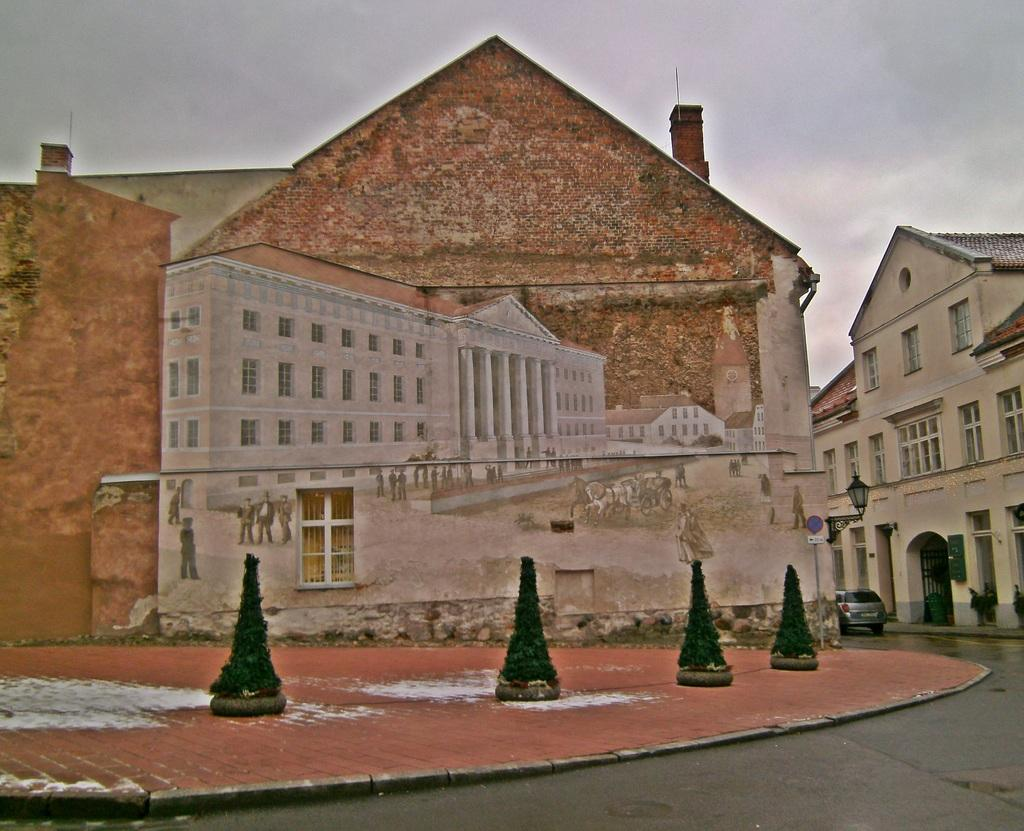What type of structures can be seen in the image? There are buildings in the image. What else can be found in the image besides buildings? There are plants, a motor vehicle, street lights, and a sign board in the image. What might be used for illumination at night in the image? Street lights are present in the image for illumination. What is visible in the background of the image? The sky is visible in the background of the image. Where is the volleyball court located in the image? There is no volleyball court present in the image. What type of flooring is visible in the image? The image does not show any flooring, as it is focused on outdoor structures and elements. 